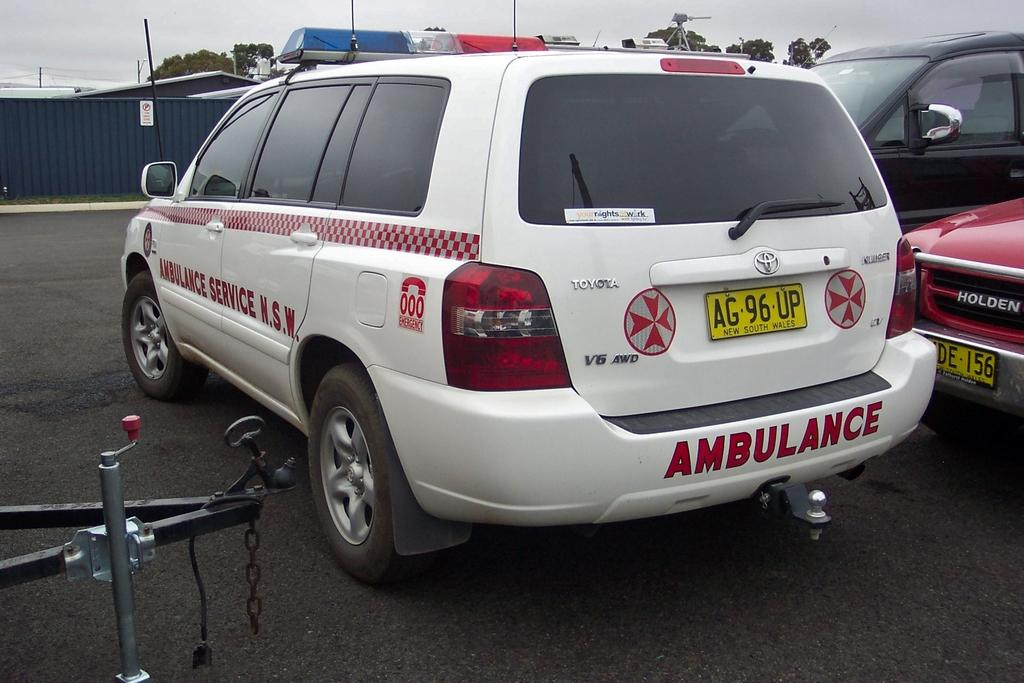What type of vehicles can be seen on the surface in the image? There are cars on the surface in the image. What is visible in the background of the image? There is a roof top and trees visible in the background of the image. What else can be seen in the sky in the background of the image? The sky is visible in the background of the image. Can you tell me how the guide is helping the cars in the image? There is no guide present in the image, and therefore no assistance can be observed. 